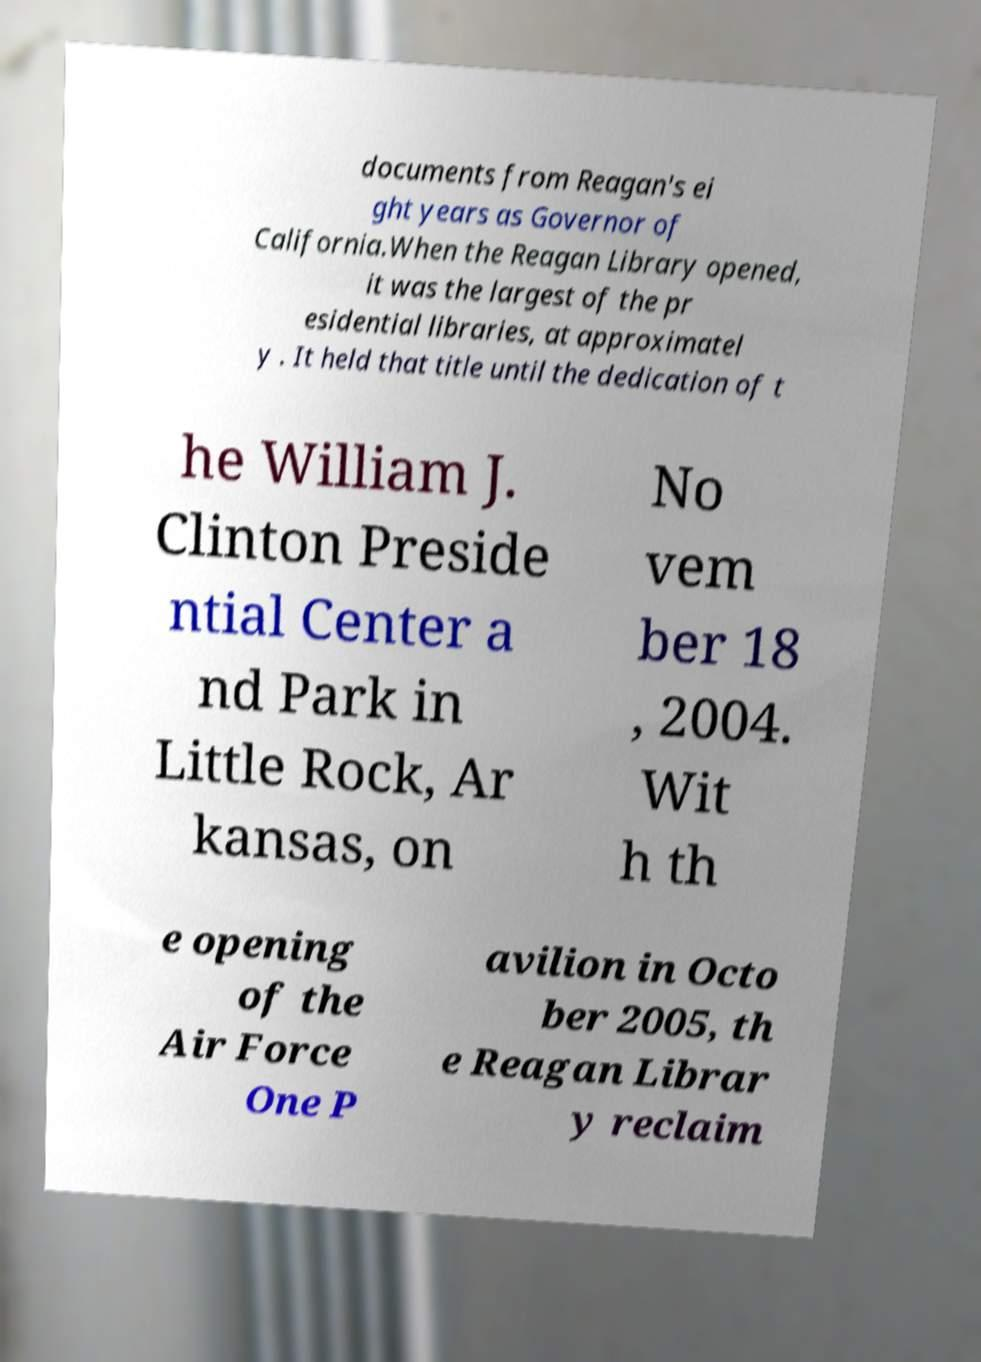Could you extract and type out the text from this image? documents from Reagan's ei ght years as Governor of California.When the Reagan Library opened, it was the largest of the pr esidential libraries, at approximatel y . It held that title until the dedication of t he William J. Clinton Preside ntial Center a nd Park in Little Rock, Ar kansas, on No vem ber 18 , 2004. Wit h th e opening of the Air Force One P avilion in Octo ber 2005, th e Reagan Librar y reclaim 